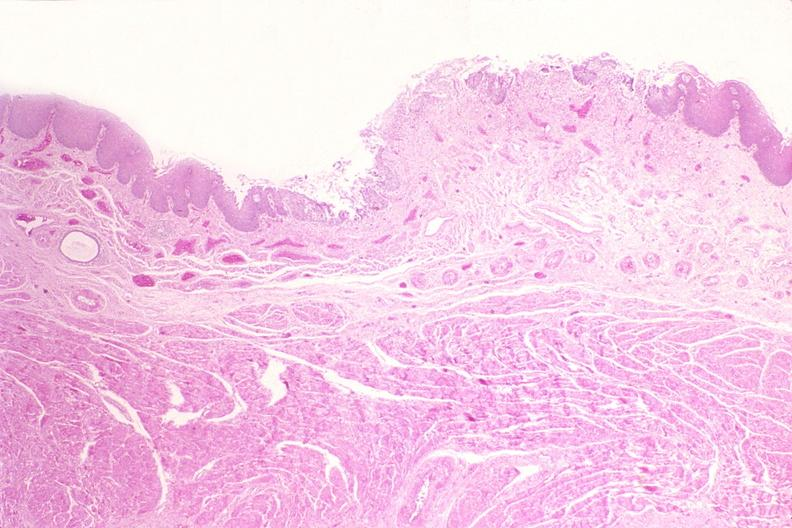does this image show esophagus, herpes, ulcers?
Answer the question using a single word or phrase. Yes 